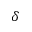<formula> <loc_0><loc_0><loc_500><loc_500>\delta</formula> 